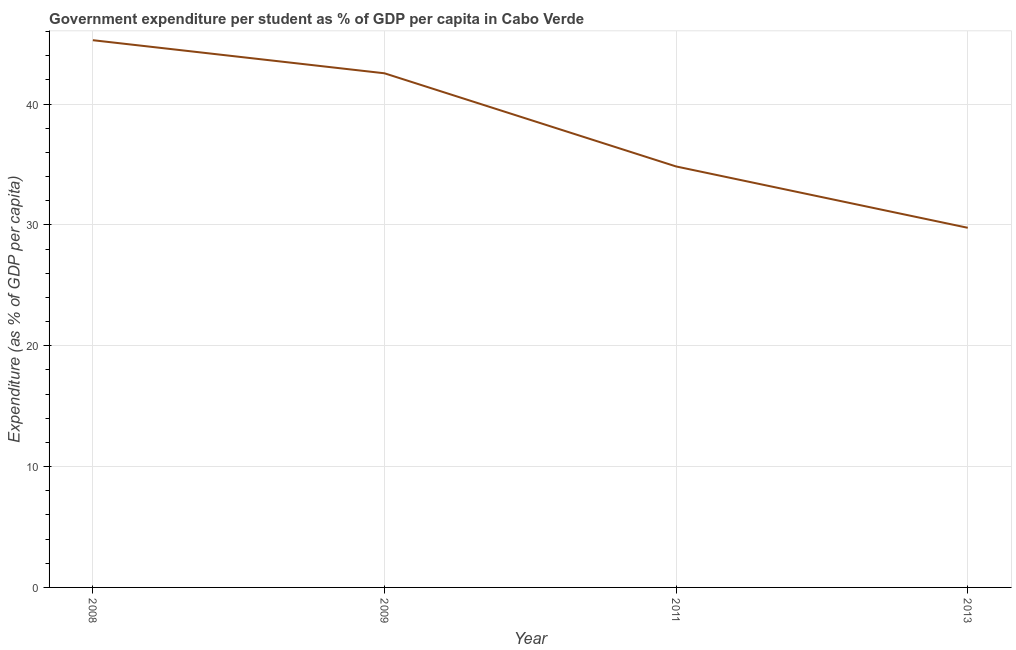What is the government expenditure per student in 2013?
Offer a terse response. 29.76. Across all years, what is the maximum government expenditure per student?
Provide a short and direct response. 45.28. Across all years, what is the minimum government expenditure per student?
Ensure brevity in your answer.  29.76. In which year was the government expenditure per student maximum?
Your answer should be very brief. 2008. What is the sum of the government expenditure per student?
Provide a succinct answer. 152.43. What is the difference between the government expenditure per student in 2008 and 2009?
Keep it short and to the point. 2.74. What is the average government expenditure per student per year?
Provide a short and direct response. 38.11. What is the median government expenditure per student?
Provide a succinct answer. 38.69. Do a majority of the years between 2013 and 2011 (inclusive) have government expenditure per student greater than 38 %?
Your answer should be compact. No. What is the ratio of the government expenditure per student in 2009 to that in 2011?
Your answer should be compact. 1.22. What is the difference between the highest and the second highest government expenditure per student?
Your answer should be very brief. 2.74. Is the sum of the government expenditure per student in 2011 and 2013 greater than the maximum government expenditure per student across all years?
Ensure brevity in your answer.  Yes. What is the difference between the highest and the lowest government expenditure per student?
Your response must be concise. 15.52. In how many years, is the government expenditure per student greater than the average government expenditure per student taken over all years?
Ensure brevity in your answer.  2. Does the government expenditure per student monotonically increase over the years?
Ensure brevity in your answer.  No. Are the values on the major ticks of Y-axis written in scientific E-notation?
Ensure brevity in your answer.  No. What is the title of the graph?
Your response must be concise. Government expenditure per student as % of GDP per capita in Cabo Verde. What is the label or title of the X-axis?
Ensure brevity in your answer.  Year. What is the label or title of the Y-axis?
Make the answer very short. Expenditure (as % of GDP per capita). What is the Expenditure (as % of GDP per capita) of 2008?
Provide a succinct answer. 45.28. What is the Expenditure (as % of GDP per capita) of 2009?
Provide a short and direct response. 42.55. What is the Expenditure (as % of GDP per capita) in 2011?
Your answer should be very brief. 34.84. What is the Expenditure (as % of GDP per capita) of 2013?
Provide a short and direct response. 29.76. What is the difference between the Expenditure (as % of GDP per capita) in 2008 and 2009?
Your answer should be very brief. 2.74. What is the difference between the Expenditure (as % of GDP per capita) in 2008 and 2011?
Make the answer very short. 10.45. What is the difference between the Expenditure (as % of GDP per capita) in 2008 and 2013?
Make the answer very short. 15.52. What is the difference between the Expenditure (as % of GDP per capita) in 2009 and 2011?
Your response must be concise. 7.71. What is the difference between the Expenditure (as % of GDP per capita) in 2009 and 2013?
Make the answer very short. 12.78. What is the difference between the Expenditure (as % of GDP per capita) in 2011 and 2013?
Offer a very short reply. 5.08. What is the ratio of the Expenditure (as % of GDP per capita) in 2008 to that in 2009?
Your response must be concise. 1.06. What is the ratio of the Expenditure (as % of GDP per capita) in 2008 to that in 2013?
Offer a terse response. 1.52. What is the ratio of the Expenditure (as % of GDP per capita) in 2009 to that in 2011?
Provide a succinct answer. 1.22. What is the ratio of the Expenditure (as % of GDP per capita) in 2009 to that in 2013?
Keep it short and to the point. 1.43. What is the ratio of the Expenditure (as % of GDP per capita) in 2011 to that in 2013?
Ensure brevity in your answer.  1.17. 